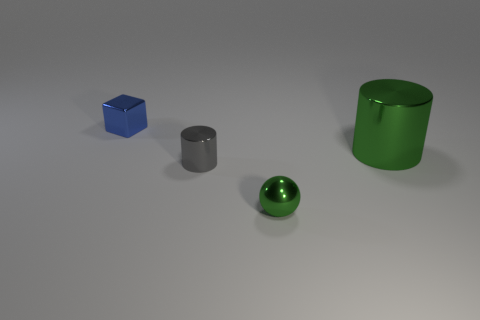If these objects were part of a set, what kind of set do you think it would be and why? These objects might belong to a geometric shape set used for educational purposes. Each one represents a fundamental 3D shape—a cube, a sphere, and a cylinder—commonly used to help learners understand spatial dimensions, volume, and the properties of different geometrical figures. 